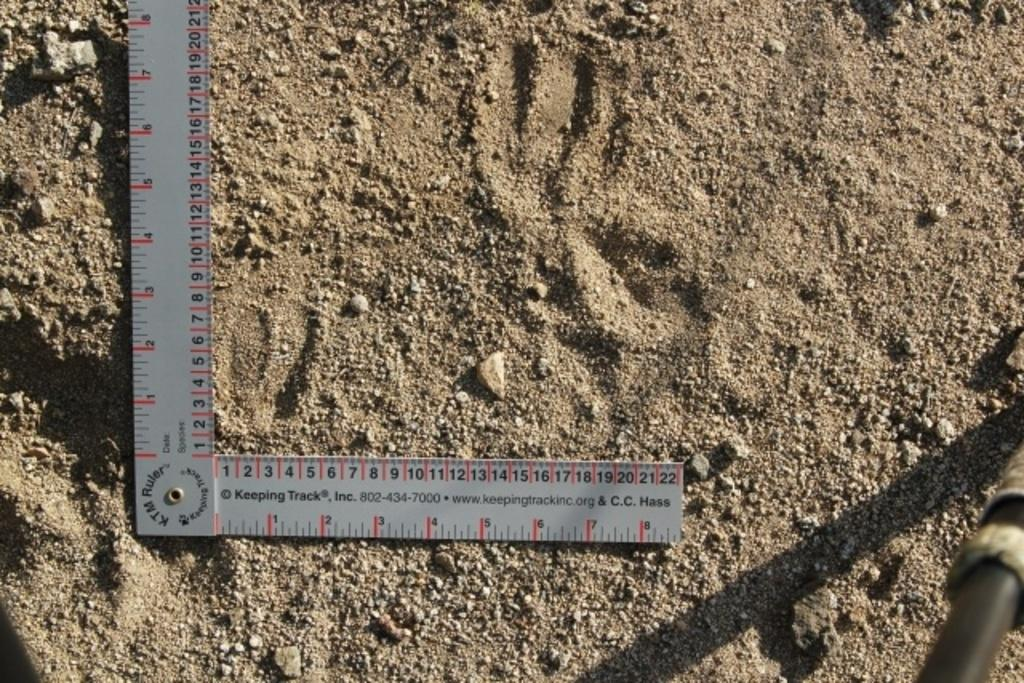Provide a one-sentence caption for the provided image. A K.T.M. branded L-shaped ruler sits on coarse sand. 